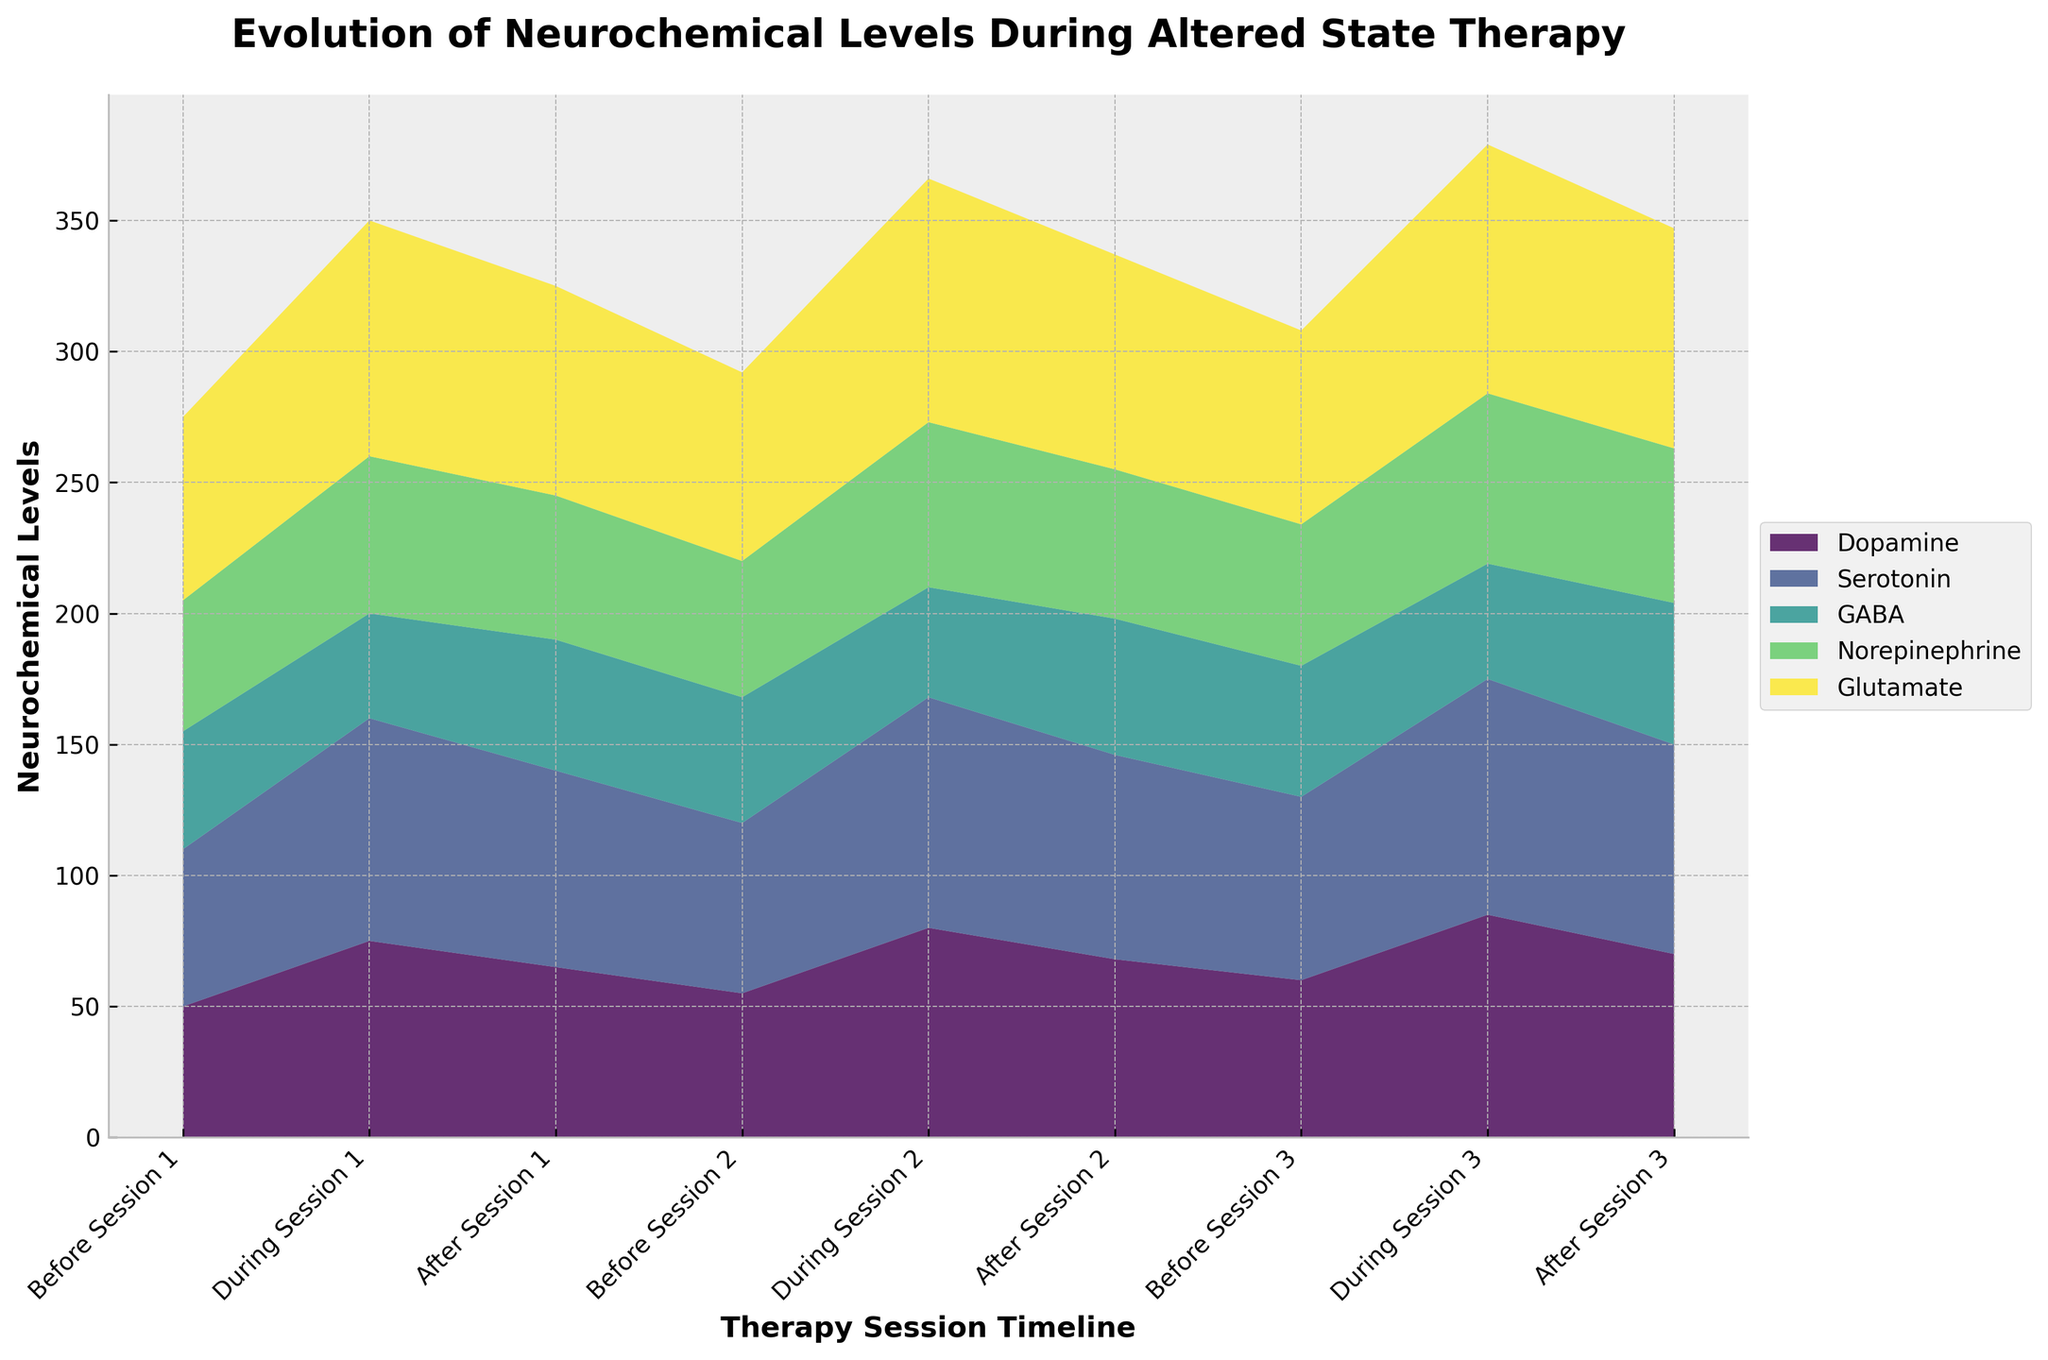What are the five neurochemicals being tracked in the plot? The five neurochemicals are shown in the legend on the right side of the plot. They are represented in different colors and labels.
Answer: Dopamine, Serotonin, GABA, Norepinephrine, Glutamate Which neurochemical shows the highest level during any therapy session? By examining the peak levels during the different therapy sessions in the plot, the neurochemical with the highest level is Glutamate, particularly during the sessions.
Answer: Glutamate How do Dopamine levels change from before to after Session 2? Before Session 2, Dopamine levels are at 55. During Session 2, they increase to 80, and after the session, they slightly decrease to 68.
Answer: Increase then decrease During which session is Serotonin at its highest level? Looking at the peak values in the plot, Serotonin reaches its highest level during Session 3, at 90.
Answer: Session 3 How does GABA change during Session 1 compared to its level before the session? GABA levels drop from 45 before Session 1 to 40 during Session 1.
Answer: It decreases Compare the levels of Norepinephrine before and after the therapy sessions. Before Session 1, Norepinephrine is at 50. It increases to 55 after the session. Similarly, for Session 2, it’s 52 before and 57 after. For Session 3, it’s 54 before and 59 after. In all three instances, Norepinephrine levels increase after the session.
Answer: Levels increase after each session What is the average level of Glutamate during the therapy sessions? Glutamate levels during the sessions are 90, 93, and 95. Summing these up: 90 + 93 + 95 = 278. Dividing by 3 sessions: 278 / 3 = 92.67.
Answer: 92.67 Which neurochemical remains relatively stable throughout the therapy sessions? By observing the plot for less fluctuation in levels, GABA remains relatively stable compared to others, varying between 40 and 54.
Answer: GABA How does the total neurochemical level change during Session 3 compared to before Session 3? Before Session 3, the levels are Dopamine: 60, Serotonin: 70, GABA: 50, Norepinephrine: 54, Glutamate: 74. Their sum is 308. During Session 3, the levels are Dopamine: 85, Serotonin: 90, GABA: 44, Norepinephrine: 65, Glutamate: 95. Their sum is 379. The total levels increased by 379 - 308 = 71.
Answer: Increased by 71 What trend can you visualize for the Dopamine levels over the three therapy sessions? Dopamine levels increase during each session and decrease slightly after the session, but the after-session levels are higher than the previous before-session levels.
Answer: Increase during sessions, slight decrease after 